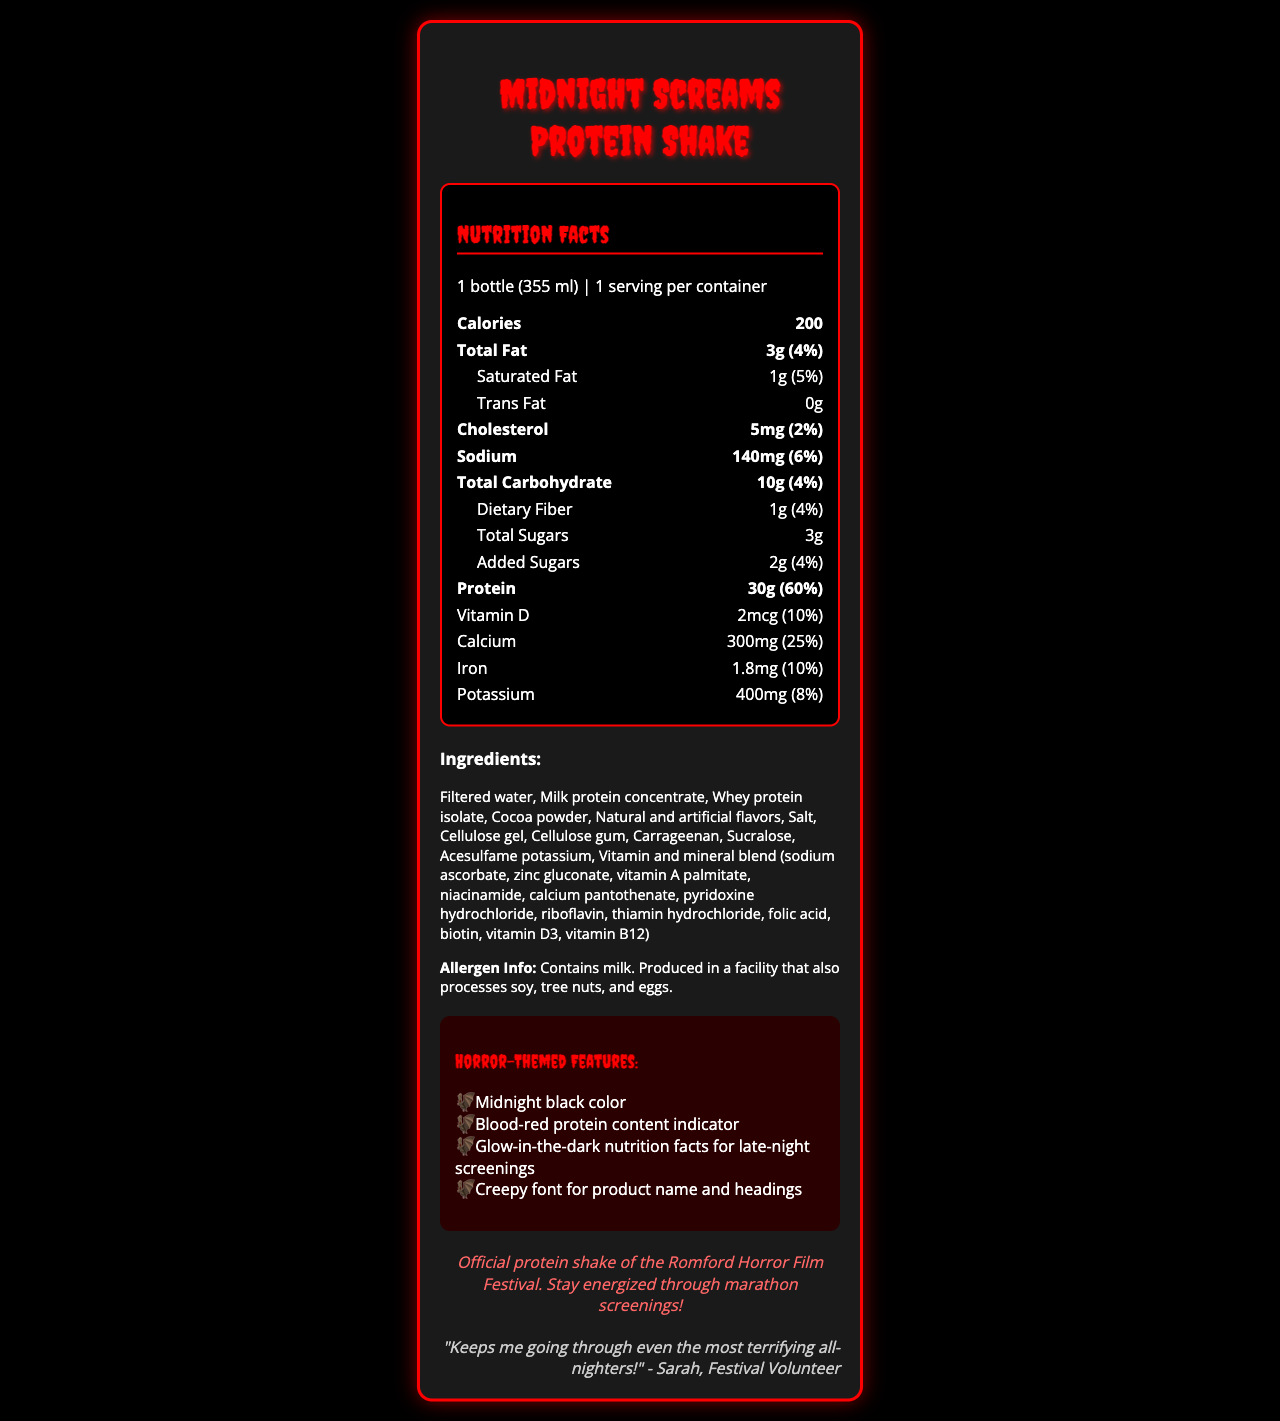what is the serving size? The serving size is listed under the nutrition facts section, stating that one bottle is equivalent to 355 ml.
Answer: 1 bottle (355 ml) how many calories are there per serving? The calorie count is prominently displayed under the nutrition facts, stating 200 calories per serving.
Answer: 200 how much protein does the shake contain? The protein content is clearly shown in the nutrition facts, listing 30g of protein per serving.
Answer: 30g What is the daily value percentage of calcium in this shake? The daily value for calcium is listed next to its amount, showing 25%.
Answer: 25% how much sodium is in the shake? The sodium content is displayed under the nutrition facts, stating 140mg per serving.
Answer: 140mg which of the following is not an ingredient in the shake? A. Cocoa powder B. Strawberry extract C. Milk protein concentrate The list of ingredients includes cocoa powder and milk protein concentrate but not strawberry extract.
Answer: B what percentage of the daily value of vitamin D does the shake provide? A. 5% B. 8% C. 10% D. 20% The shake provides 10% of the daily value of vitamin D, as indicated in the nutrition facts.
Answer: C is there any trans fat in the shake? The nutrition facts indicate that the trans fat content is 0g, meaning there is no trans fat in the shake.
Answer: No does the shake contain any allergens? The allergen information states that the shake contains milk and is produced in a facility that also processes soy, tree nuts, and eggs.
Answer: Yes summarize the main nutritional and thematic features of the Midnight Screams Protein Shake. The summary covers the high-protein content, the caloric details, and the horror-themed design, which makes it suitable for long nights of film screenings.
Answer: The Midnight Screams Protein Shake is a high-protein beverage designed for horror film enthusiasts, featuring 30g of protein and 200 calories per bottle. It has unique horror-themed features like a midnight black color and glow-in-the-dark nutrition facts, making it the official protein shake of the Romford Horror Film Festival. what is the exact amount of sucralose in the shake? The document lists sucralose as an ingredient but does not specify the exact amount.
Answer: Not enough information what is the main theme of the horror features? The horror features include a midnight black color, blood-red protein content indicator, glow-in-the-dark nutrition facts, and a creepy font, all aligning with a horror theme.
Answer: Horror-themed elements like midnight black color and blood-red indicators 